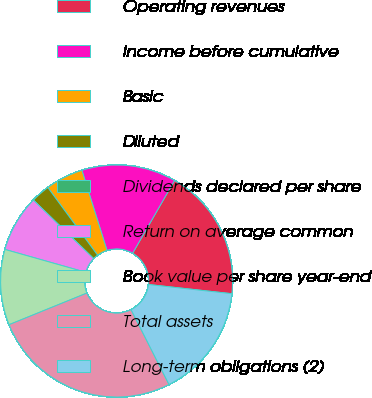Convert chart to OTSL. <chart><loc_0><loc_0><loc_500><loc_500><pie_chart><fcel>Operating revenues<fcel>Income before cumulative<fcel>Basic<fcel>Diluted<fcel>Dividends declared per share<fcel>Return on average common<fcel>Book value per share year-end<fcel>Total assets<fcel>Long-term obligations (2)<nl><fcel>18.42%<fcel>13.16%<fcel>5.26%<fcel>2.63%<fcel>0.0%<fcel>7.89%<fcel>10.53%<fcel>26.32%<fcel>15.79%<nl></chart> 